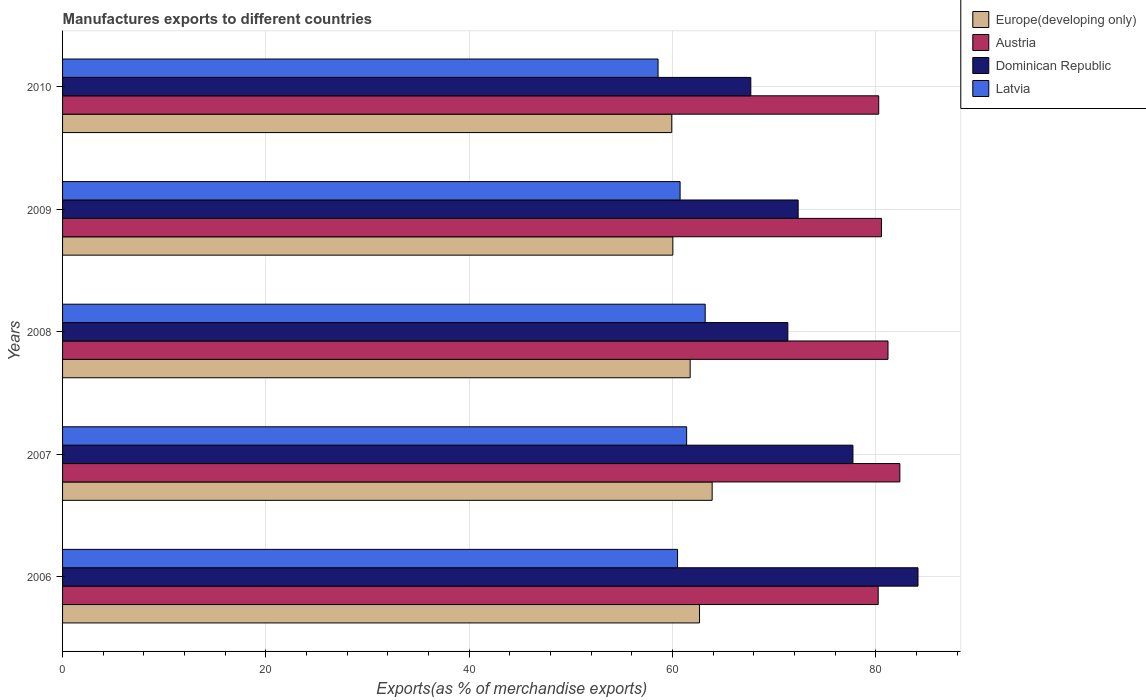Are the number of bars on each tick of the Y-axis equal?
Provide a short and direct response. Yes. In how many cases, is the number of bars for a given year not equal to the number of legend labels?
Give a very brief answer. 0. What is the percentage of exports to different countries in Dominican Republic in 2006?
Keep it short and to the point. 84.15. Across all years, what is the maximum percentage of exports to different countries in Dominican Republic?
Ensure brevity in your answer.  84.15. Across all years, what is the minimum percentage of exports to different countries in Europe(developing only)?
Offer a very short reply. 59.93. What is the total percentage of exports to different countries in Austria in the graph?
Make the answer very short. 404.66. What is the difference between the percentage of exports to different countries in Dominican Republic in 2006 and that in 2009?
Give a very brief answer. 11.79. What is the difference between the percentage of exports to different countries in Europe(developing only) in 2006 and the percentage of exports to different countries in Latvia in 2010?
Provide a succinct answer. 4.08. What is the average percentage of exports to different countries in Austria per year?
Your answer should be very brief. 80.93. In the year 2007, what is the difference between the percentage of exports to different countries in Europe(developing only) and percentage of exports to different countries in Dominican Republic?
Keep it short and to the point. -13.85. What is the ratio of the percentage of exports to different countries in Latvia in 2006 to that in 2008?
Keep it short and to the point. 0.96. Is the percentage of exports to different countries in Austria in 2007 less than that in 2008?
Offer a terse response. No. What is the difference between the highest and the second highest percentage of exports to different countries in Austria?
Provide a succinct answer. 1.17. What is the difference between the highest and the lowest percentage of exports to different countries in Austria?
Your response must be concise. 2.13. Is it the case that in every year, the sum of the percentage of exports to different countries in Dominican Republic and percentage of exports to different countries in Latvia is greater than the sum of percentage of exports to different countries in Europe(developing only) and percentage of exports to different countries in Austria?
Make the answer very short. No. What does the 4th bar from the top in 2006 represents?
Provide a short and direct response. Europe(developing only). What does the 1st bar from the bottom in 2010 represents?
Provide a short and direct response. Europe(developing only). How many bars are there?
Offer a terse response. 20. How many years are there in the graph?
Ensure brevity in your answer.  5. What is the difference between two consecutive major ticks on the X-axis?
Provide a short and direct response. 20. Does the graph contain any zero values?
Your answer should be compact. No. How many legend labels are there?
Provide a short and direct response. 4. How are the legend labels stacked?
Your answer should be very brief. Vertical. What is the title of the graph?
Give a very brief answer. Manufactures exports to different countries. Does "Congo (Democratic)" appear as one of the legend labels in the graph?
Make the answer very short. No. What is the label or title of the X-axis?
Provide a short and direct response. Exports(as % of merchandise exports). What is the Exports(as % of merchandise exports) of Europe(developing only) in 2006?
Provide a short and direct response. 62.66. What is the Exports(as % of merchandise exports) of Austria in 2006?
Offer a terse response. 80.24. What is the Exports(as % of merchandise exports) of Dominican Republic in 2006?
Give a very brief answer. 84.15. What is the Exports(as % of merchandise exports) of Latvia in 2006?
Keep it short and to the point. 60.5. What is the Exports(as % of merchandise exports) of Europe(developing only) in 2007?
Provide a short and direct response. 63.9. What is the Exports(as % of merchandise exports) in Austria in 2007?
Offer a very short reply. 82.37. What is the Exports(as % of merchandise exports) in Dominican Republic in 2007?
Your answer should be compact. 77.75. What is the Exports(as % of merchandise exports) of Latvia in 2007?
Your answer should be very brief. 61.39. What is the Exports(as % of merchandise exports) in Europe(developing only) in 2008?
Give a very brief answer. 61.74. What is the Exports(as % of merchandise exports) in Austria in 2008?
Make the answer very short. 81.2. What is the Exports(as % of merchandise exports) of Dominican Republic in 2008?
Ensure brevity in your answer.  71.35. What is the Exports(as % of merchandise exports) in Latvia in 2008?
Ensure brevity in your answer.  63.22. What is the Exports(as % of merchandise exports) in Europe(developing only) in 2009?
Provide a short and direct response. 60.04. What is the Exports(as % of merchandise exports) in Austria in 2009?
Your response must be concise. 80.56. What is the Exports(as % of merchandise exports) of Dominican Republic in 2009?
Your answer should be very brief. 72.36. What is the Exports(as % of merchandise exports) of Latvia in 2009?
Your answer should be compact. 60.75. What is the Exports(as % of merchandise exports) in Europe(developing only) in 2010?
Your answer should be very brief. 59.93. What is the Exports(as % of merchandise exports) of Austria in 2010?
Provide a short and direct response. 80.29. What is the Exports(as % of merchandise exports) of Dominican Republic in 2010?
Ensure brevity in your answer.  67.71. What is the Exports(as % of merchandise exports) of Latvia in 2010?
Provide a succinct answer. 58.58. Across all years, what is the maximum Exports(as % of merchandise exports) in Europe(developing only)?
Offer a terse response. 63.9. Across all years, what is the maximum Exports(as % of merchandise exports) in Austria?
Your answer should be compact. 82.37. Across all years, what is the maximum Exports(as % of merchandise exports) in Dominican Republic?
Offer a very short reply. 84.15. Across all years, what is the maximum Exports(as % of merchandise exports) in Latvia?
Offer a very short reply. 63.22. Across all years, what is the minimum Exports(as % of merchandise exports) in Europe(developing only)?
Offer a terse response. 59.93. Across all years, what is the minimum Exports(as % of merchandise exports) of Austria?
Ensure brevity in your answer.  80.24. Across all years, what is the minimum Exports(as % of merchandise exports) in Dominican Republic?
Offer a very short reply. 67.71. Across all years, what is the minimum Exports(as % of merchandise exports) in Latvia?
Offer a very short reply. 58.58. What is the total Exports(as % of merchandise exports) in Europe(developing only) in the graph?
Your answer should be very brief. 308.27. What is the total Exports(as % of merchandise exports) of Austria in the graph?
Provide a short and direct response. 404.66. What is the total Exports(as % of merchandise exports) in Dominican Republic in the graph?
Keep it short and to the point. 373.33. What is the total Exports(as % of merchandise exports) of Latvia in the graph?
Make the answer very short. 304.44. What is the difference between the Exports(as % of merchandise exports) of Europe(developing only) in 2006 and that in 2007?
Offer a terse response. -1.24. What is the difference between the Exports(as % of merchandise exports) in Austria in 2006 and that in 2007?
Your response must be concise. -2.13. What is the difference between the Exports(as % of merchandise exports) in Dominican Republic in 2006 and that in 2007?
Your answer should be compact. 6.4. What is the difference between the Exports(as % of merchandise exports) of Latvia in 2006 and that in 2007?
Offer a terse response. -0.89. What is the difference between the Exports(as % of merchandise exports) of Europe(developing only) in 2006 and that in 2008?
Provide a succinct answer. 0.92. What is the difference between the Exports(as % of merchandise exports) of Austria in 2006 and that in 2008?
Your answer should be compact. -0.97. What is the difference between the Exports(as % of merchandise exports) of Dominican Republic in 2006 and that in 2008?
Offer a very short reply. 12.8. What is the difference between the Exports(as % of merchandise exports) of Latvia in 2006 and that in 2008?
Provide a succinct answer. -2.72. What is the difference between the Exports(as % of merchandise exports) of Europe(developing only) in 2006 and that in 2009?
Offer a very short reply. 2.63. What is the difference between the Exports(as % of merchandise exports) in Austria in 2006 and that in 2009?
Make the answer very short. -0.32. What is the difference between the Exports(as % of merchandise exports) in Dominican Republic in 2006 and that in 2009?
Make the answer very short. 11.79. What is the difference between the Exports(as % of merchandise exports) in Latvia in 2006 and that in 2009?
Your answer should be compact. -0.25. What is the difference between the Exports(as % of merchandise exports) in Europe(developing only) in 2006 and that in 2010?
Your answer should be very brief. 2.73. What is the difference between the Exports(as % of merchandise exports) in Austria in 2006 and that in 2010?
Your response must be concise. -0.05. What is the difference between the Exports(as % of merchandise exports) in Dominican Republic in 2006 and that in 2010?
Give a very brief answer. 16.45. What is the difference between the Exports(as % of merchandise exports) in Latvia in 2006 and that in 2010?
Keep it short and to the point. 1.92. What is the difference between the Exports(as % of merchandise exports) in Europe(developing only) in 2007 and that in 2008?
Make the answer very short. 2.16. What is the difference between the Exports(as % of merchandise exports) in Austria in 2007 and that in 2008?
Provide a succinct answer. 1.17. What is the difference between the Exports(as % of merchandise exports) in Dominican Republic in 2007 and that in 2008?
Your answer should be very brief. 6.4. What is the difference between the Exports(as % of merchandise exports) in Latvia in 2007 and that in 2008?
Your answer should be very brief. -1.83. What is the difference between the Exports(as % of merchandise exports) in Europe(developing only) in 2007 and that in 2009?
Offer a terse response. 3.87. What is the difference between the Exports(as % of merchandise exports) of Austria in 2007 and that in 2009?
Ensure brevity in your answer.  1.81. What is the difference between the Exports(as % of merchandise exports) of Dominican Republic in 2007 and that in 2009?
Your answer should be very brief. 5.39. What is the difference between the Exports(as % of merchandise exports) in Latvia in 2007 and that in 2009?
Your response must be concise. 0.64. What is the difference between the Exports(as % of merchandise exports) of Europe(developing only) in 2007 and that in 2010?
Ensure brevity in your answer.  3.97. What is the difference between the Exports(as % of merchandise exports) in Austria in 2007 and that in 2010?
Provide a short and direct response. 2.08. What is the difference between the Exports(as % of merchandise exports) of Dominican Republic in 2007 and that in 2010?
Provide a succinct answer. 10.05. What is the difference between the Exports(as % of merchandise exports) in Latvia in 2007 and that in 2010?
Offer a very short reply. 2.81. What is the difference between the Exports(as % of merchandise exports) of Europe(developing only) in 2008 and that in 2009?
Give a very brief answer. 1.7. What is the difference between the Exports(as % of merchandise exports) in Austria in 2008 and that in 2009?
Give a very brief answer. 0.64. What is the difference between the Exports(as % of merchandise exports) of Dominican Republic in 2008 and that in 2009?
Ensure brevity in your answer.  -1.01. What is the difference between the Exports(as % of merchandise exports) of Latvia in 2008 and that in 2009?
Offer a terse response. 2.47. What is the difference between the Exports(as % of merchandise exports) of Europe(developing only) in 2008 and that in 2010?
Offer a very short reply. 1.81. What is the difference between the Exports(as % of merchandise exports) in Austria in 2008 and that in 2010?
Your response must be concise. 0.91. What is the difference between the Exports(as % of merchandise exports) of Dominican Republic in 2008 and that in 2010?
Offer a terse response. 3.64. What is the difference between the Exports(as % of merchandise exports) in Latvia in 2008 and that in 2010?
Give a very brief answer. 4.64. What is the difference between the Exports(as % of merchandise exports) in Europe(developing only) in 2009 and that in 2010?
Your response must be concise. 0.11. What is the difference between the Exports(as % of merchandise exports) in Austria in 2009 and that in 2010?
Keep it short and to the point. 0.27. What is the difference between the Exports(as % of merchandise exports) in Dominican Republic in 2009 and that in 2010?
Offer a very short reply. 4.66. What is the difference between the Exports(as % of merchandise exports) of Latvia in 2009 and that in 2010?
Keep it short and to the point. 2.17. What is the difference between the Exports(as % of merchandise exports) of Europe(developing only) in 2006 and the Exports(as % of merchandise exports) of Austria in 2007?
Keep it short and to the point. -19.71. What is the difference between the Exports(as % of merchandise exports) in Europe(developing only) in 2006 and the Exports(as % of merchandise exports) in Dominican Republic in 2007?
Your answer should be very brief. -15.09. What is the difference between the Exports(as % of merchandise exports) of Europe(developing only) in 2006 and the Exports(as % of merchandise exports) of Latvia in 2007?
Give a very brief answer. 1.27. What is the difference between the Exports(as % of merchandise exports) in Austria in 2006 and the Exports(as % of merchandise exports) in Dominican Republic in 2007?
Provide a short and direct response. 2.48. What is the difference between the Exports(as % of merchandise exports) in Austria in 2006 and the Exports(as % of merchandise exports) in Latvia in 2007?
Your answer should be very brief. 18.84. What is the difference between the Exports(as % of merchandise exports) of Dominican Republic in 2006 and the Exports(as % of merchandise exports) of Latvia in 2007?
Offer a very short reply. 22.76. What is the difference between the Exports(as % of merchandise exports) in Europe(developing only) in 2006 and the Exports(as % of merchandise exports) in Austria in 2008?
Your answer should be compact. -18.54. What is the difference between the Exports(as % of merchandise exports) of Europe(developing only) in 2006 and the Exports(as % of merchandise exports) of Dominican Republic in 2008?
Make the answer very short. -8.69. What is the difference between the Exports(as % of merchandise exports) in Europe(developing only) in 2006 and the Exports(as % of merchandise exports) in Latvia in 2008?
Your answer should be very brief. -0.56. What is the difference between the Exports(as % of merchandise exports) of Austria in 2006 and the Exports(as % of merchandise exports) of Dominican Republic in 2008?
Give a very brief answer. 8.89. What is the difference between the Exports(as % of merchandise exports) in Austria in 2006 and the Exports(as % of merchandise exports) in Latvia in 2008?
Give a very brief answer. 17.02. What is the difference between the Exports(as % of merchandise exports) in Dominican Republic in 2006 and the Exports(as % of merchandise exports) in Latvia in 2008?
Ensure brevity in your answer.  20.93. What is the difference between the Exports(as % of merchandise exports) in Europe(developing only) in 2006 and the Exports(as % of merchandise exports) in Austria in 2009?
Give a very brief answer. -17.9. What is the difference between the Exports(as % of merchandise exports) of Europe(developing only) in 2006 and the Exports(as % of merchandise exports) of Dominican Republic in 2009?
Provide a short and direct response. -9.7. What is the difference between the Exports(as % of merchandise exports) in Europe(developing only) in 2006 and the Exports(as % of merchandise exports) in Latvia in 2009?
Your response must be concise. 1.91. What is the difference between the Exports(as % of merchandise exports) in Austria in 2006 and the Exports(as % of merchandise exports) in Dominican Republic in 2009?
Provide a short and direct response. 7.87. What is the difference between the Exports(as % of merchandise exports) of Austria in 2006 and the Exports(as % of merchandise exports) of Latvia in 2009?
Your answer should be compact. 19.49. What is the difference between the Exports(as % of merchandise exports) of Dominican Republic in 2006 and the Exports(as % of merchandise exports) of Latvia in 2009?
Make the answer very short. 23.4. What is the difference between the Exports(as % of merchandise exports) in Europe(developing only) in 2006 and the Exports(as % of merchandise exports) in Austria in 2010?
Offer a very short reply. -17.63. What is the difference between the Exports(as % of merchandise exports) of Europe(developing only) in 2006 and the Exports(as % of merchandise exports) of Dominican Republic in 2010?
Provide a succinct answer. -5.04. What is the difference between the Exports(as % of merchandise exports) in Europe(developing only) in 2006 and the Exports(as % of merchandise exports) in Latvia in 2010?
Provide a short and direct response. 4.08. What is the difference between the Exports(as % of merchandise exports) in Austria in 2006 and the Exports(as % of merchandise exports) in Dominican Republic in 2010?
Offer a very short reply. 12.53. What is the difference between the Exports(as % of merchandise exports) in Austria in 2006 and the Exports(as % of merchandise exports) in Latvia in 2010?
Provide a short and direct response. 21.65. What is the difference between the Exports(as % of merchandise exports) in Dominican Republic in 2006 and the Exports(as % of merchandise exports) in Latvia in 2010?
Your answer should be very brief. 25.57. What is the difference between the Exports(as % of merchandise exports) of Europe(developing only) in 2007 and the Exports(as % of merchandise exports) of Austria in 2008?
Make the answer very short. -17.3. What is the difference between the Exports(as % of merchandise exports) in Europe(developing only) in 2007 and the Exports(as % of merchandise exports) in Dominican Republic in 2008?
Provide a short and direct response. -7.45. What is the difference between the Exports(as % of merchandise exports) in Europe(developing only) in 2007 and the Exports(as % of merchandise exports) in Latvia in 2008?
Keep it short and to the point. 0.68. What is the difference between the Exports(as % of merchandise exports) in Austria in 2007 and the Exports(as % of merchandise exports) in Dominican Republic in 2008?
Your response must be concise. 11.02. What is the difference between the Exports(as % of merchandise exports) in Austria in 2007 and the Exports(as % of merchandise exports) in Latvia in 2008?
Your answer should be compact. 19.15. What is the difference between the Exports(as % of merchandise exports) of Dominican Republic in 2007 and the Exports(as % of merchandise exports) of Latvia in 2008?
Keep it short and to the point. 14.53. What is the difference between the Exports(as % of merchandise exports) in Europe(developing only) in 2007 and the Exports(as % of merchandise exports) in Austria in 2009?
Offer a terse response. -16.66. What is the difference between the Exports(as % of merchandise exports) in Europe(developing only) in 2007 and the Exports(as % of merchandise exports) in Dominican Republic in 2009?
Your answer should be very brief. -8.46. What is the difference between the Exports(as % of merchandise exports) of Europe(developing only) in 2007 and the Exports(as % of merchandise exports) of Latvia in 2009?
Provide a succinct answer. 3.15. What is the difference between the Exports(as % of merchandise exports) in Austria in 2007 and the Exports(as % of merchandise exports) in Dominican Republic in 2009?
Your response must be concise. 10.01. What is the difference between the Exports(as % of merchandise exports) of Austria in 2007 and the Exports(as % of merchandise exports) of Latvia in 2009?
Give a very brief answer. 21.62. What is the difference between the Exports(as % of merchandise exports) of Dominican Republic in 2007 and the Exports(as % of merchandise exports) of Latvia in 2009?
Ensure brevity in your answer.  17. What is the difference between the Exports(as % of merchandise exports) in Europe(developing only) in 2007 and the Exports(as % of merchandise exports) in Austria in 2010?
Provide a succinct answer. -16.39. What is the difference between the Exports(as % of merchandise exports) in Europe(developing only) in 2007 and the Exports(as % of merchandise exports) in Dominican Republic in 2010?
Provide a succinct answer. -3.8. What is the difference between the Exports(as % of merchandise exports) of Europe(developing only) in 2007 and the Exports(as % of merchandise exports) of Latvia in 2010?
Ensure brevity in your answer.  5.32. What is the difference between the Exports(as % of merchandise exports) of Austria in 2007 and the Exports(as % of merchandise exports) of Dominican Republic in 2010?
Offer a terse response. 14.66. What is the difference between the Exports(as % of merchandise exports) of Austria in 2007 and the Exports(as % of merchandise exports) of Latvia in 2010?
Your answer should be very brief. 23.79. What is the difference between the Exports(as % of merchandise exports) in Dominican Republic in 2007 and the Exports(as % of merchandise exports) in Latvia in 2010?
Keep it short and to the point. 19.17. What is the difference between the Exports(as % of merchandise exports) of Europe(developing only) in 2008 and the Exports(as % of merchandise exports) of Austria in 2009?
Keep it short and to the point. -18.82. What is the difference between the Exports(as % of merchandise exports) in Europe(developing only) in 2008 and the Exports(as % of merchandise exports) in Dominican Republic in 2009?
Provide a short and direct response. -10.63. What is the difference between the Exports(as % of merchandise exports) of Austria in 2008 and the Exports(as % of merchandise exports) of Dominican Republic in 2009?
Your response must be concise. 8.84. What is the difference between the Exports(as % of merchandise exports) in Austria in 2008 and the Exports(as % of merchandise exports) in Latvia in 2009?
Provide a short and direct response. 20.45. What is the difference between the Exports(as % of merchandise exports) of Dominican Republic in 2008 and the Exports(as % of merchandise exports) of Latvia in 2009?
Make the answer very short. 10.6. What is the difference between the Exports(as % of merchandise exports) in Europe(developing only) in 2008 and the Exports(as % of merchandise exports) in Austria in 2010?
Your answer should be very brief. -18.55. What is the difference between the Exports(as % of merchandise exports) of Europe(developing only) in 2008 and the Exports(as % of merchandise exports) of Dominican Republic in 2010?
Provide a succinct answer. -5.97. What is the difference between the Exports(as % of merchandise exports) in Europe(developing only) in 2008 and the Exports(as % of merchandise exports) in Latvia in 2010?
Your response must be concise. 3.16. What is the difference between the Exports(as % of merchandise exports) in Austria in 2008 and the Exports(as % of merchandise exports) in Dominican Republic in 2010?
Ensure brevity in your answer.  13.5. What is the difference between the Exports(as % of merchandise exports) in Austria in 2008 and the Exports(as % of merchandise exports) in Latvia in 2010?
Offer a very short reply. 22.62. What is the difference between the Exports(as % of merchandise exports) in Dominican Republic in 2008 and the Exports(as % of merchandise exports) in Latvia in 2010?
Keep it short and to the point. 12.77. What is the difference between the Exports(as % of merchandise exports) in Europe(developing only) in 2009 and the Exports(as % of merchandise exports) in Austria in 2010?
Make the answer very short. -20.25. What is the difference between the Exports(as % of merchandise exports) of Europe(developing only) in 2009 and the Exports(as % of merchandise exports) of Dominican Republic in 2010?
Offer a terse response. -7.67. What is the difference between the Exports(as % of merchandise exports) of Europe(developing only) in 2009 and the Exports(as % of merchandise exports) of Latvia in 2010?
Give a very brief answer. 1.45. What is the difference between the Exports(as % of merchandise exports) of Austria in 2009 and the Exports(as % of merchandise exports) of Dominican Republic in 2010?
Your answer should be compact. 12.85. What is the difference between the Exports(as % of merchandise exports) of Austria in 2009 and the Exports(as % of merchandise exports) of Latvia in 2010?
Your answer should be compact. 21.98. What is the difference between the Exports(as % of merchandise exports) of Dominican Republic in 2009 and the Exports(as % of merchandise exports) of Latvia in 2010?
Offer a very short reply. 13.78. What is the average Exports(as % of merchandise exports) of Europe(developing only) per year?
Make the answer very short. 61.65. What is the average Exports(as % of merchandise exports) in Austria per year?
Offer a very short reply. 80.93. What is the average Exports(as % of merchandise exports) of Dominican Republic per year?
Your answer should be very brief. 74.67. What is the average Exports(as % of merchandise exports) of Latvia per year?
Offer a very short reply. 60.89. In the year 2006, what is the difference between the Exports(as % of merchandise exports) in Europe(developing only) and Exports(as % of merchandise exports) in Austria?
Ensure brevity in your answer.  -17.57. In the year 2006, what is the difference between the Exports(as % of merchandise exports) of Europe(developing only) and Exports(as % of merchandise exports) of Dominican Republic?
Provide a short and direct response. -21.49. In the year 2006, what is the difference between the Exports(as % of merchandise exports) in Europe(developing only) and Exports(as % of merchandise exports) in Latvia?
Offer a very short reply. 2.16. In the year 2006, what is the difference between the Exports(as % of merchandise exports) in Austria and Exports(as % of merchandise exports) in Dominican Republic?
Provide a short and direct response. -3.92. In the year 2006, what is the difference between the Exports(as % of merchandise exports) of Austria and Exports(as % of merchandise exports) of Latvia?
Provide a short and direct response. 19.74. In the year 2006, what is the difference between the Exports(as % of merchandise exports) in Dominican Republic and Exports(as % of merchandise exports) in Latvia?
Your response must be concise. 23.65. In the year 2007, what is the difference between the Exports(as % of merchandise exports) in Europe(developing only) and Exports(as % of merchandise exports) in Austria?
Offer a very short reply. -18.47. In the year 2007, what is the difference between the Exports(as % of merchandise exports) of Europe(developing only) and Exports(as % of merchandise exports) of Dominican Republic?
Your answer should be very brief. -13.85. In the year 2007, what is the difference between the Exports(as % of merchandise exports) of Europe(developing only) and Exports(as % of merchandise exports) of Latvia?
Your response must be concise. 2.51. In the year 2007, what is the difference between the Exports(as % of merchandise exports) in Austria and Exports(as % of merchandise exports) in Dominican Republic?
Offer a terse response. 4.62. In the year 2007, what is the difference between the Exports(as % of merchandise exports) in Austria and Exports(as % of merchandise exports) in Latvia?
Your answer should be compact. 20.98. In the year 2007, what is the difference between the Exports(as % of merchandise exports) of Dominican Republic and Exports(as % of merchandise exports) of Latvia?
Your answer should be compact. 16.36. In the year 2008, what is the difference between the Exports(as % of merchandise exports) in Europe(developing only) and Exports(as % of merchandise exports) in Austria?
Keep it short and to the point. -19.46. In the year 2008, what is the difference between the Exports(as % of merchandise exports) in Europe(developing only) and Exports(as % of merchandise exports) in Dominican Republic?
Provide a succinct answer. -9.61. In the year 2008, what is the difference between the Exports(as % of merchandise exports) of Europe(developing only) and Exports(as % of merchandise exports) of Latvia?
Provide a succinct answer. -1.48. In the year 2008, what is the difference between the Exports(as % of merchandise exports) of Austria and Exports(as % of merchandise exports) of Dominican Republic?
Keep it short and to the point. 9.85. In the year 2008, what is the difference between the Exports(as % of merchandise exports) in Austria and Exports(as % of merchandise exports) in Latvia?
Give a very brief answer. 17.98. In the year 2008, what is the difference between the Exports(as % of merchandise exports) in Dominican Republic and Exports(as % of merchandise exports) in Latvia?
Keep it short and to the point. 8.13. In the year 2009, what is the difference between the Exports(as % of merchandise exports) in Europe(developing only) and Exports(as % of merchandise exports) in Austria?
Your answer should be compact. -20.52. In the year 2009, what is the difference between the Exports(as % of merchandise exports) in Europe(developing only) and Exports(as % of merchandise exports) in Dominican Republic?
Offer a very short reply. -12.33. In the year 2009, what is the difference between the Exports(as % of merchandise exports) of Europe(developing only) and Exports(as % of merchandise exports) of Latvia?
Keep it short and to the point. -0.71. In the year 2009, what is the difference between the Exports(as % of merchandise exports) in Austria and Exports(as % of merchandise exports) in Dominican Republic?
Make the answer very short. 8.2. In the year 2009, what is the difference between the Exports(as % of merchandise exports) in Austria and Exports(as % of merchandise exports) in Latvia?
Provide a succinct answer. 19.81. In the year 2009, what is the difference between the Exports(as % of merchandise exports) in Dominican Republic and Exports(as % of merchandise exports) in Latvia?
Ensure brevity in your answer.  11.61. In the year 2010, what is the difference between the Exports(as % of merchandise exports) in Europe(developing only) and Exports(as % of merchandise exports) in Austria?
Offer a very short reply. -20.36. In the year 2010, what is the difference between the Exports(as % of merchandise exports) in Europe(developing only) and Exports(as % of merchandise exports) in Dominican Republic?
Keep it short and to the point. -7.78. In the year 2010, what is the difference between the Exports(as % of merchandise exports) in Europe(developing only) and Exports(as % of merchandise exports) in Latvia?
Your answer should be compact. 1.35. In the year 2010, what is the difference between the Exports(as % of merchandise exports) in Austria and Exports(as % of merchandise exports) in Dominican Republic?
Ensure brevity in your answer.  12.58. In the year 2010, what is the difference between the Exports(as % of merchandise exports) of Austria and Exports(as % of merchandise exports) of Latvia?
Your answer should be very brief. 21.71. In the year 2010, what is the difference between the Exports(as % of merchandise exports) in Dominican Republic and Exports(as % of merchandise exports) in Latvia?
Give a very brief answer. 9.12. What is the ratio of the Exports(as % of merchandise exports) of Europe(developing only) in 2006 to that in 2007?
Provide a short and direct response. 0.98. What is the ratio of the Exports(as % of merchandise exports) in Austria in 2006 to that in 2007?
Your answer should be very brief. 0.97. What is the ratio of the Exports(as % of merchandise exports) of Dominican Republic in 2006 to that in 2007?
Offer a terse response. 1.08. What is the ratio of the Exports(as % of merchandise exports) of Latvia in 2006 to that in 2007?
Keep it short and to the point. 0.99. What is the ratio of the Exports(as % of merchandise exports) in Europe(developing only) in 2006 to that in 2008?
Give a very brief answer. 1.01. What is the ratio of the Exports(as % of merchandise exports) in Austria in 2006 to that in 2008?
Your answer should be compact. 0.99. What is the ratio of the Exports(as % of merchandise exports) in Dominican Republic in 2006 to that in 2008?
Make the answer very short. 1.18. What is the ratio of the Exports(as % of merchandise exports) of Europe(developing only) in 2006 to that in 2009?
Offer a very short reply. 1.04. What is the ratio of the Exports(as % of merchandise exports) in Dominican Republic in 2006 to that in 2009?
Offer a terse response. 1.16. What is the ratio of the Exports(as % of merchandise exports) in Europe(developing only) in 2006 to that in 2010?
Give a very brief answer. 1.05. What is the ratio of the Exports(as % of merchandise exports) of Dominican Republic in 2006 to that in 2010?
Your answer should be very brief. 1.24. What is the ratio of the Exports(as % of merchandise exports) of Latvia in 2006 to that in 2010?
Offer a terse response. 1.03. What is the ratio of the Exports(as % of merchandise exports) of Europe(developing only) in 2007 to that in 2008?
Make the answer very short. 1.04. What is the ratio of the Exports(as % of merchandise exports) of Austria in 2007 to that in 2008?
Keep it short and to the point. 1.01. What is the ratio of the Exports(as % of merchandise exports) of Dominican Republic in 2007 to that in 2008?
Provide a succinct answer. 1.09. What is the ratio of the Exports(as % of merchandise exports) of Latvia in 2007 to that in 2008?
Your response must be concise. 0.97. What is the ratio of the Exports(as % of merchandise exports) in Europe(developing only) in 2007 to that in 2009?
Offer a terse response. 1.06. What is the ratio of the Exports(as % of merchandise exports) of Austria in 2007 to that in 2009?
Your answer should be compact. 1.02. What is the ratio of the Exports(as % of merchandise exports) in Dominican Republic in 2007 to that in 2009?
Ensure brevity in your answer.  1.07. What is the ratio of the Exports(as % of merchandise exports) in Latvia in 2007 to that in 2009?
Give a very brief answer. 1.01. What is the ratio of the Exports(as % of merchandise exports) in Europe(developing only) in 2007 to that in 2010?
Offer a very short reply. 1.07. What is the ratio of the Exports(as % of merchandise exports) in Austria in 2007 to that in 2010?
Ensure brevity in your answer.  1.03. What is the ratio of the Exports(as % of merchandise exports) in Dominican Republic in 2007 to that in 2010?
Ensure brevity in your answer.  1.15. What is the ratio of the Exports(as % of merchandise exports) in Latvia in 2007 to that in 2010?
Offer a terse response. 1.05. What is the ratio of the Exports(as % of merchandise exports) of Europe(developing only) in 2008 to that in 2009?
Make the answer very short. 1.03. What is the ratio of the Exports(as % of merchandise exports) in Latvia in 2008 to that in 2009?
Make the answer very short. 1.04. What is the ratio of the Exports(as % of merchandise exports) of Europe(developing only) in 2008 to that in 2010?
Provide a short and direct response. 1.03. What is the ratio of the Exports(as % of merchandise exports) in Austria in 2008 to that in 2010?
Offer a terse response. 1.01. What is the ratio of the Exports(as % of merchandise exports) in Dominican Republic in 2008 to that in 2010?
Offer a terse response. 1.05. What is the ratio of the Exports(as % of merchandise exports) in Latvia in 2008 to that in 2010?
Provide a short and direct response. 1.08. What is the ratio of the Exports(as % of merchandise exports) of Austria in 2009 to that in 2010?
Keep it short and to the point. 1. What is the ratio of the Exports(as % of merchandise exports) of Dominican Republic in 2009 to that in 2010?
Provide a short and direct response. 1.07. What is the difference between the highest and the second highest Exports(as % of merchandise exports) of Europe(developing only)?
Offer a very short reply. 1.24. What is the difference between the highest and the second highest Exports(as % of merchandise exports) of Austria?
Provide a short and direct response. 1.17. What is the difference between the highest and the second highest Exports(as % of merchandise exports) in Dominican Republic?
Ensure brevity in your answer.  6.4. What is the difference between the highest and the second highest Exports(as % of merchandise exports) of Latvia?
Offer a terse response. 1.83. What is the difference between the highest and the lowest Exports(as % of merchandise exports) in Europe(developing only)?
Ensure brevity in your answer.  3.97. What is the difference between the highest and the lowest Exports(as % of merchandise exports) of Austria?
Provide a short and direct response. 2.13. What is the difference between the highest and the lowest Exports(as % of merchandise exports) of Dominican Republic?
Make the answer very short. 16.45. What is the difference between the highest and the lowest Exports(as % of merchandise exports) of Latvia?
Give a very brief answer. 4.64. 